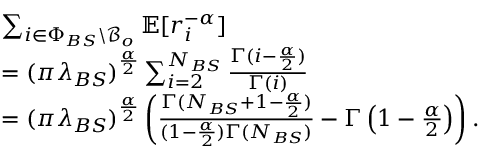Convert formula to latex. <formula><loc_0><loc_0><loc_500><loc_500>\begin{array} { r l } & { \sum _ { i \in \Phi _ { B S } \ \mathcal { B } _ { o } } \mathbb { E } [ r _ { i } ^ { - \alpha } ] } \\ & { = ( \pi \lambda _ { B S } ) ^ { \frac { \alpha } { 2 } } \sum _ { i = 2 } ^ { N _ { B S } } \frac { \Gamma ( i - \frac { \alpha } { 2 } ) } { \Gamma ( i ) } } \\ & { = ( \pi \lambda _ { B S } ) ^ { \frac { \alpha } { 2 } } \left ( \frac { \Gamma ( N _ { B S } + 1 - \frac { \alpha } { 2 } ) } { ( 1 - \frac { \alpha } { 2 } ) \Gamma ( N _ { B S } ) } - { \Gamma \left ( 1 - \frac { \alpha } { 2 } \right ) } \right ) . } \end{array}</formula> 